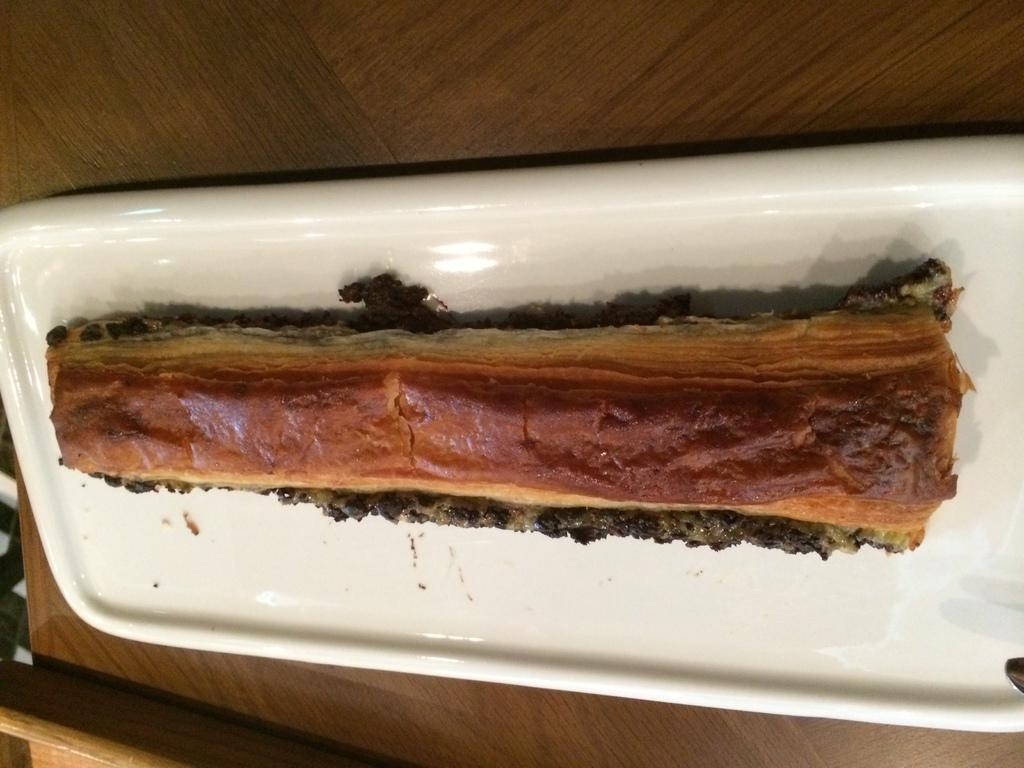What is on the plate that is visible in the image? There is a food item on the plate in the image. What is the plate placed on in the image? The plate is on a wooden board. What type of fish can be seen swimming in the image? There is no fish present in the image; it features a plate with a food item on a wooden board. 